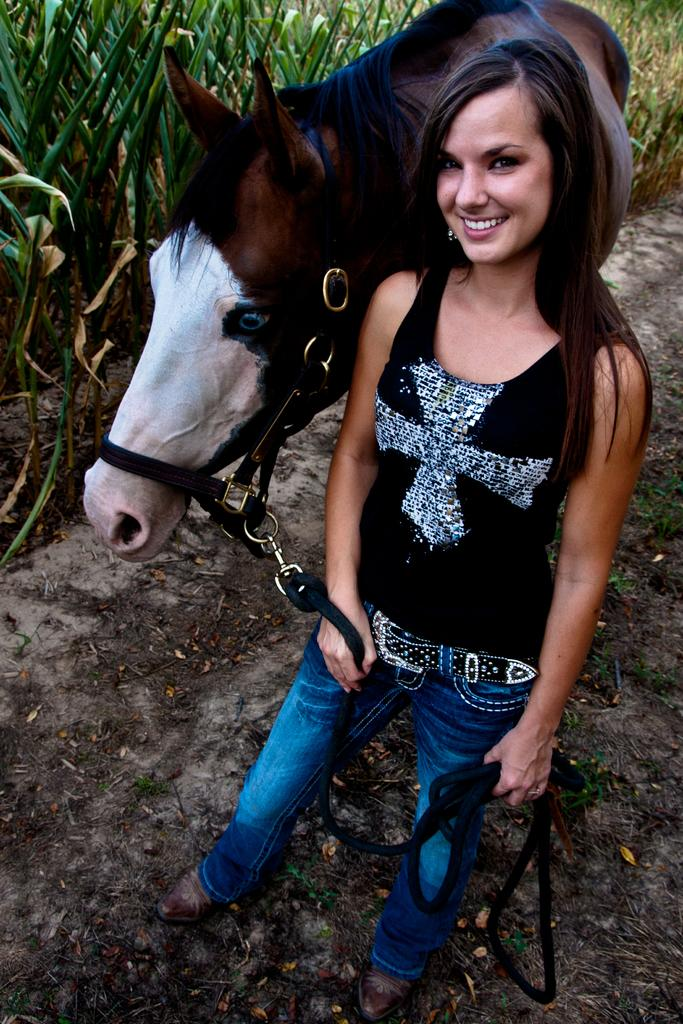What is the woman in the image wearing? The woman is wearing a black shirt and jeans. What is the woman's facial expression in the image? The woman is smiling in the image. What animal is present in the image? There is a brown horse in the image. Where is the horse located in relation to the woman? The horse is to the left of the woman. What type of structure can be seen in the image? There is a house in the image. What is growing beside the house? There are crops beside the house. How many rings are visible on the woman's body in the image? There are no rings visible on the woman's body in the image. What type of page is the horse standing on in the image? The horse is not standing on a page; it is standing on the ground in the image. 